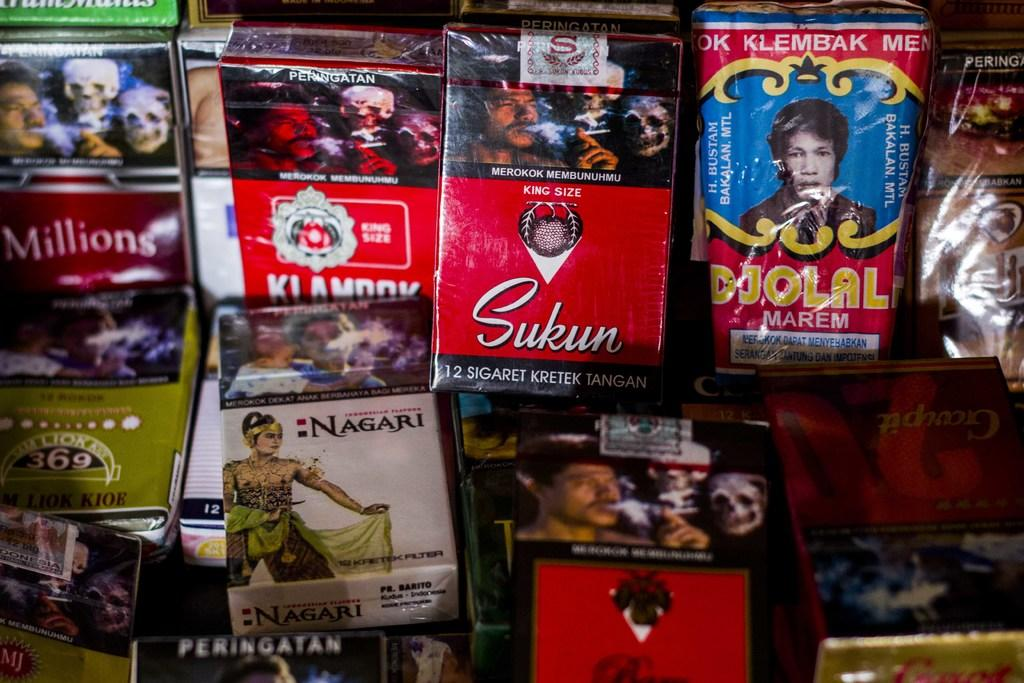What objects can be seen in the image? There are books in the image. What feature do the books have in common? The books are covered. What type of bells can be heard ringing in the image? There are no bells present in the image, so it is not possible to hear them ringing. 